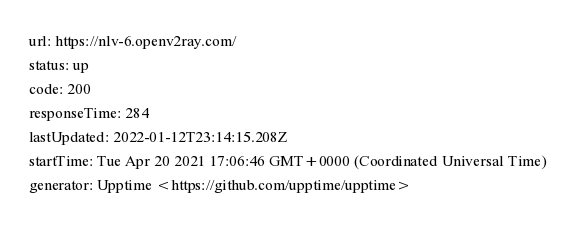Convert code to text. <code><loc_0><loc_0><loc_500><loc_500><_YAML_>url: https://nlv-6.openv2ray.com/
status: up
code: 200
responseTime: 284
lastUpdated: 2022-01-12T23:14:15.208Z
startTime: Tue Apr 20 2021 17:06:46 GMT+0000 (Coordinated Universal Time)
generator: Upptime <https://github.com/upptime/upptime>
</code> 